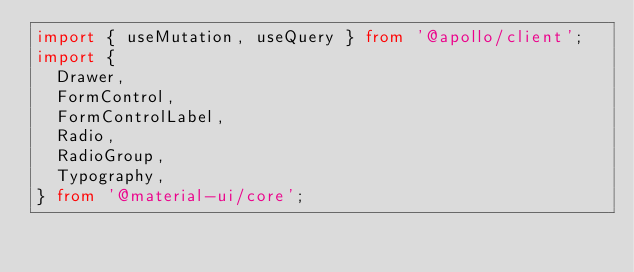<code> <loc_0><loc_0><loc_500><loc_500><_TypeScript_>import { useMutation, useQuery } from '@apollo/client';
import {
  Drawer,
  FormControl,
  FormControlLabel,
  Radio,
  RadioGroup,
  Typography,
} from '@material-ui/core';</code> 